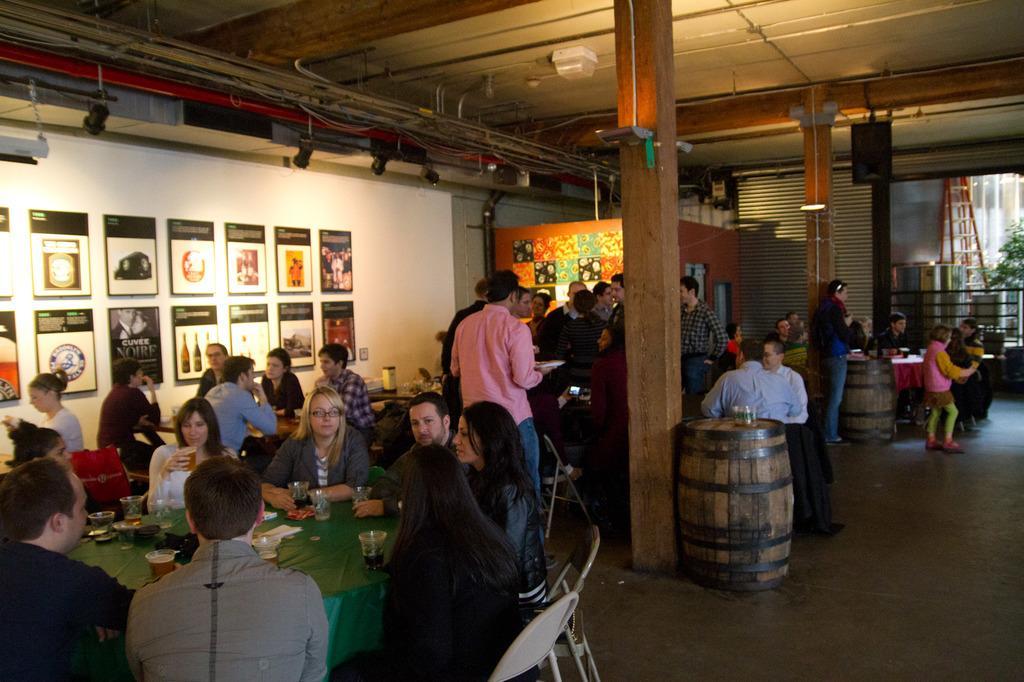Could you give a brief overview of what you see in this image? In the image we can see some people are sitting and standing and there are some chairs and tables. Behind them there is a wall, on the wall there are some posters. Top of the image there is roof and lights. Top right side of the image there is a glass wall. Behind the glass wall there is a tree. 